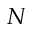<formula> <loc_0><loc_0><loc_500><loc_500>N</formula> 